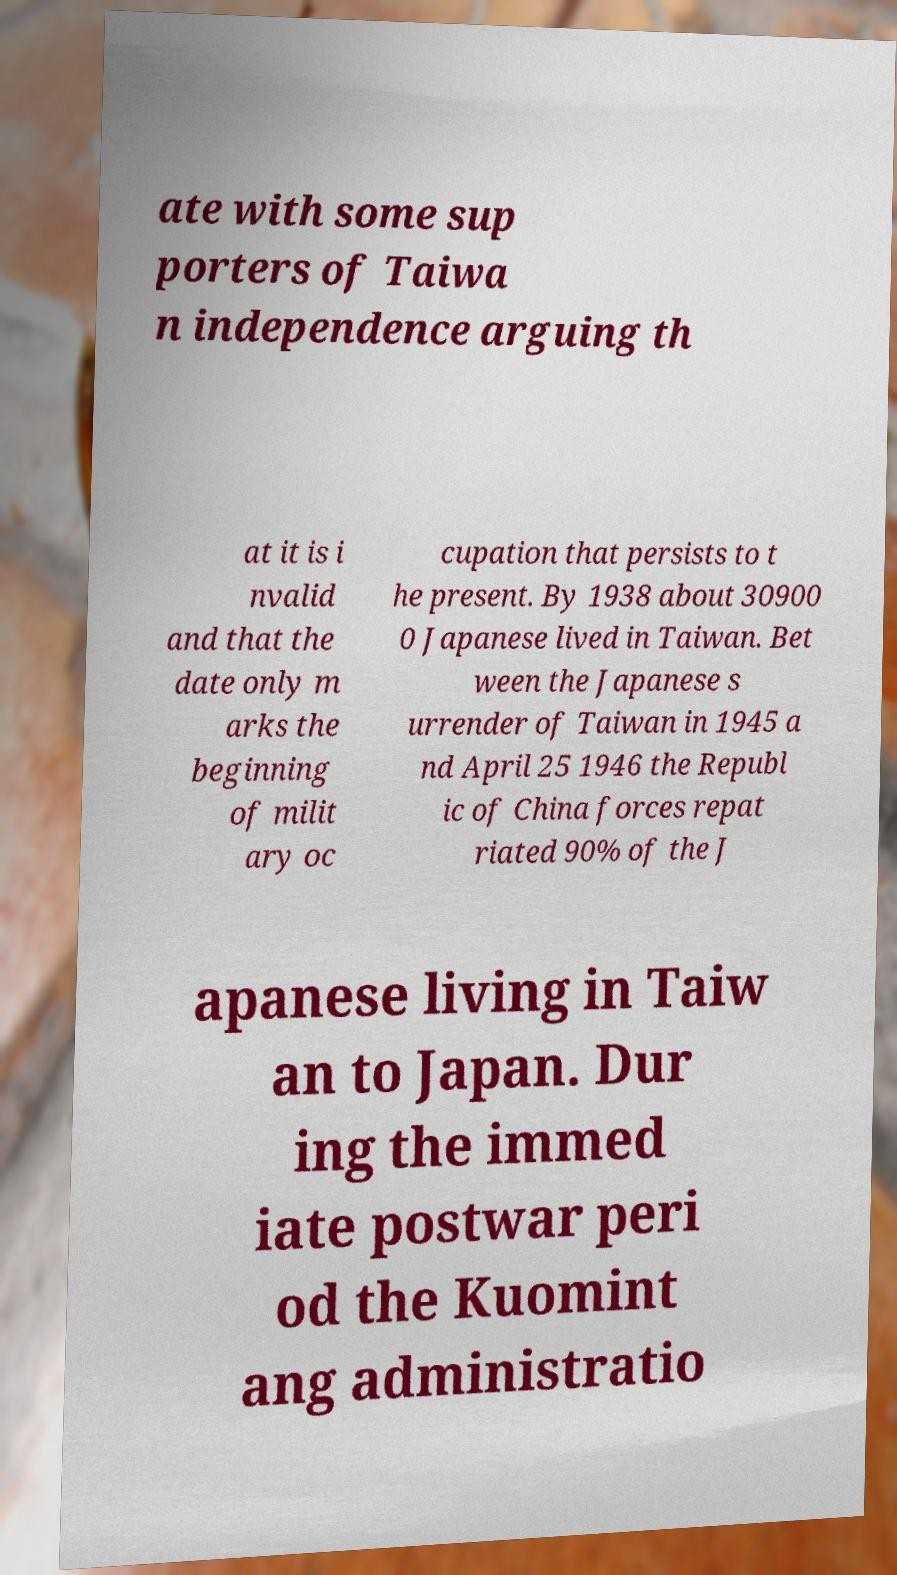What messages or text are displayed in this image? I need them in a readable, typed format. ate with some sup porters of Taiwa n independence arguing th at it is i nvalid and that the date only m arks the beginning of milit ary oc cupation that persists to t he present. By 1938 about 30900 0 Japanese lived in Taiwan. Bet ween the Japanese s urrender of Taiwan in 1945 a nd April 25 1946 the Republ ic of China forces repat riated 90% of the J apanese living in Taiw an to Japan. Dur ing the immed iate postwar peri od the Kuomint ang administratio 